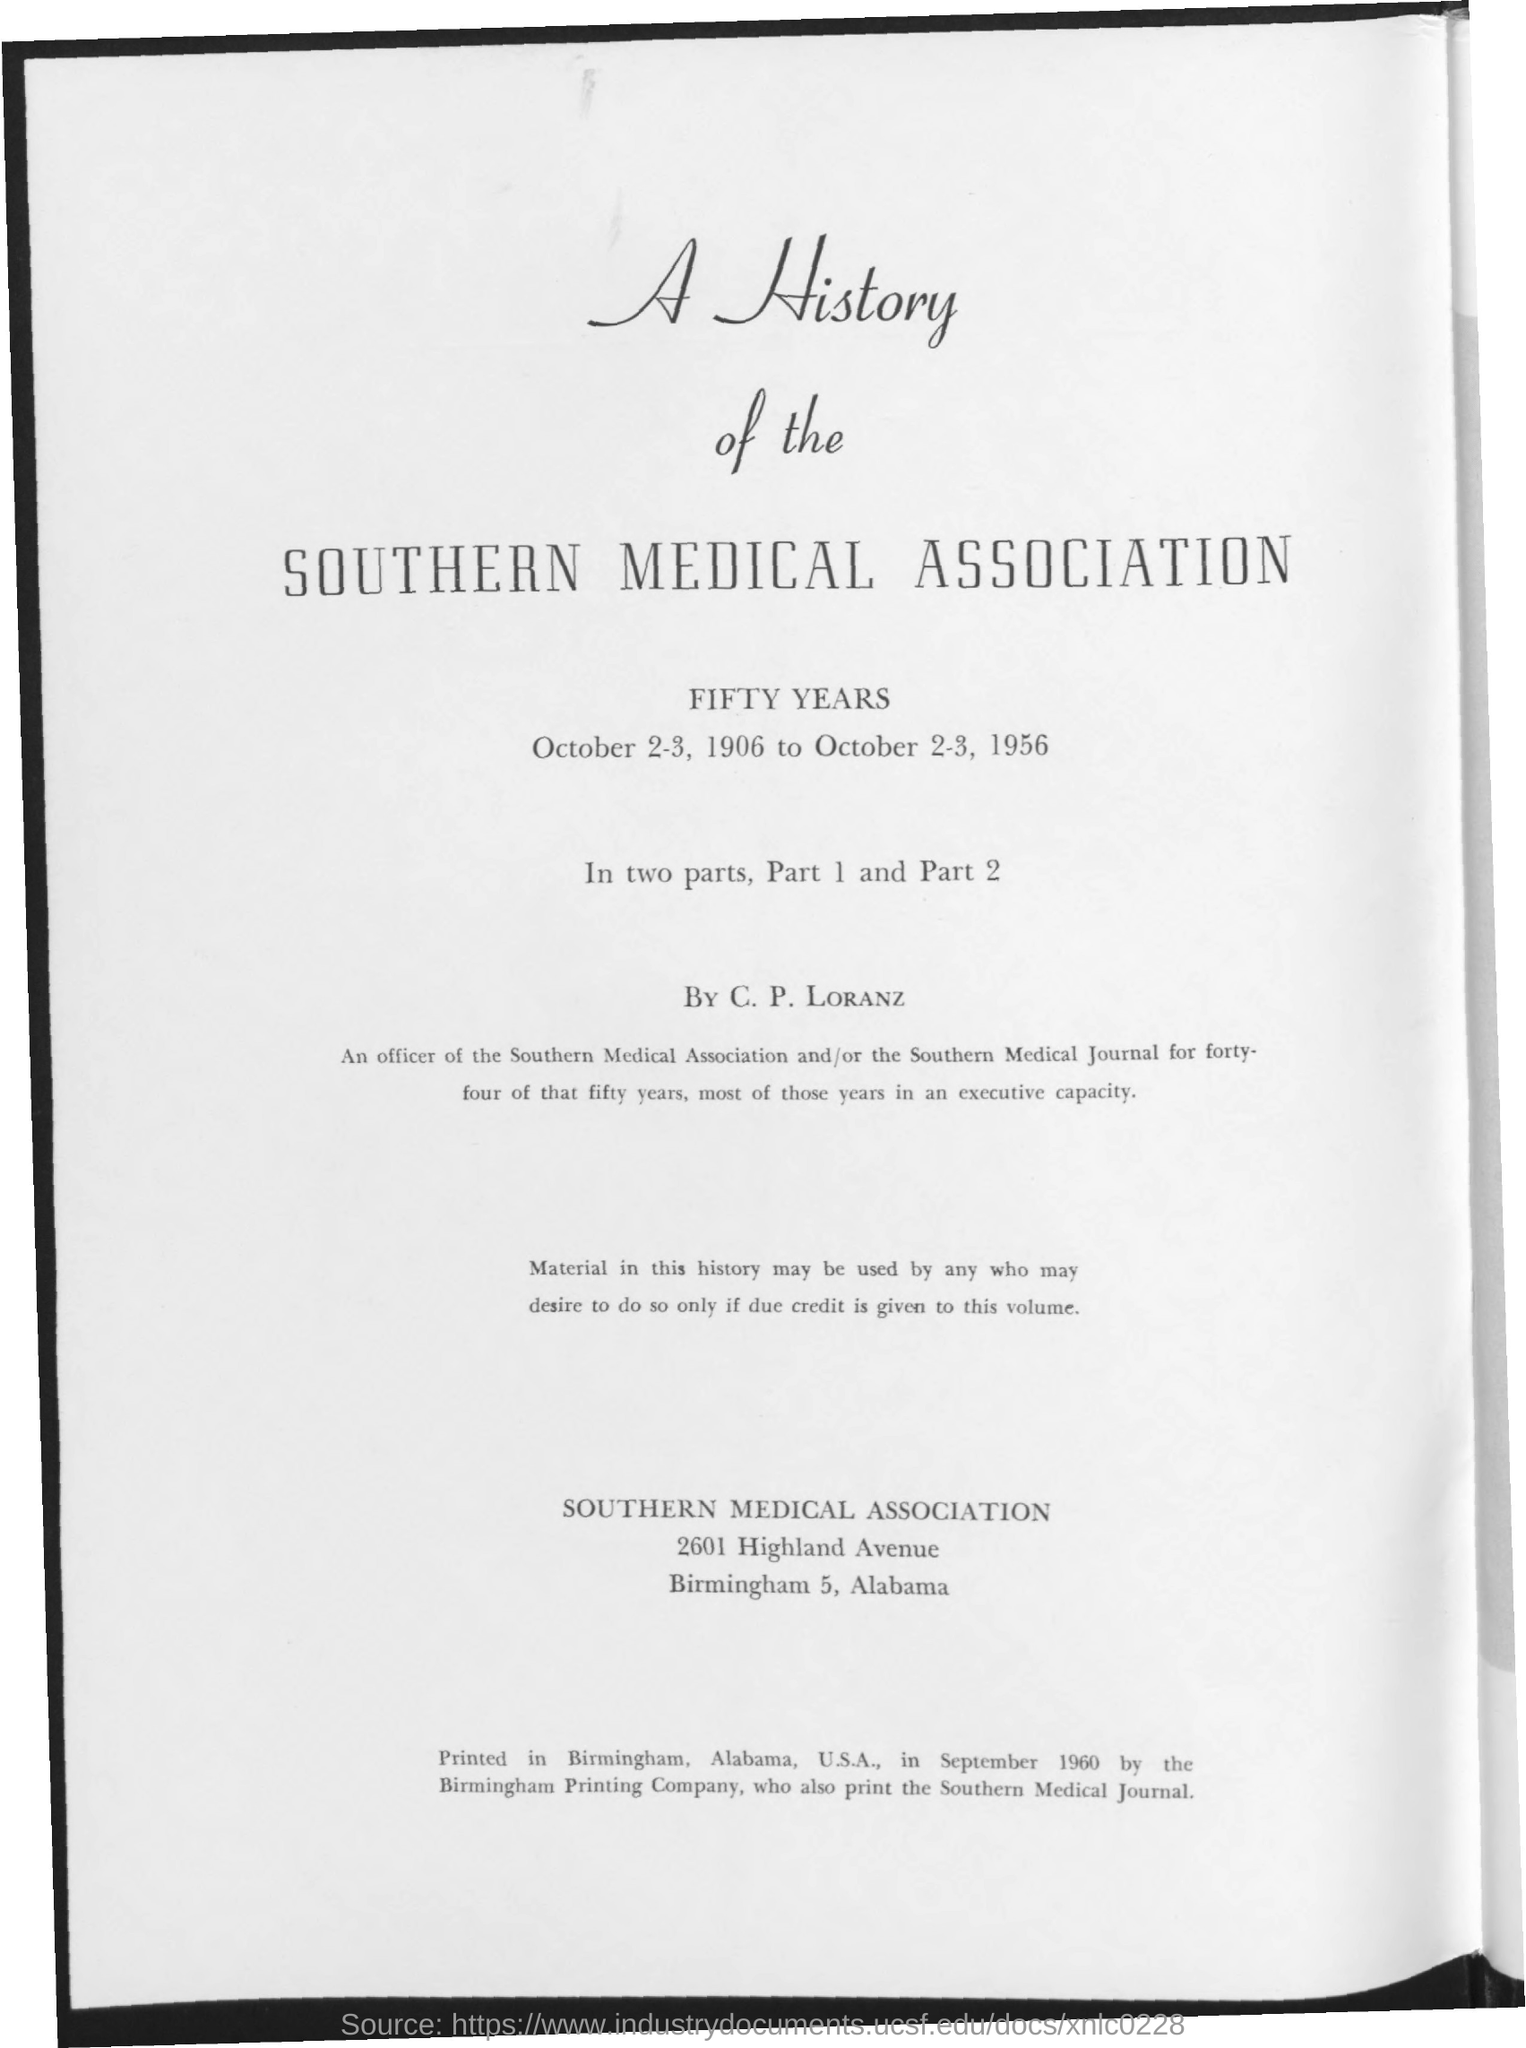Give some essential details in this illustration. The book titled "A History of the Southern Medical Association" was written by C. P. Loranz. 